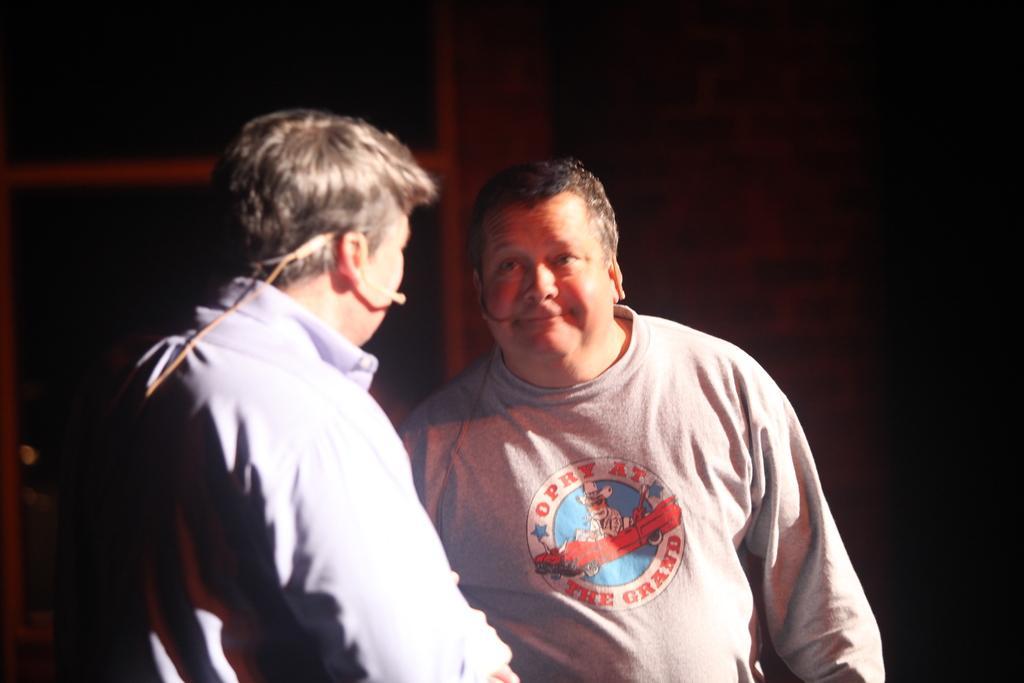Describe this image in one or two sentences. In this picture we can see there are two people standing. Behind the people there is a dark background. 